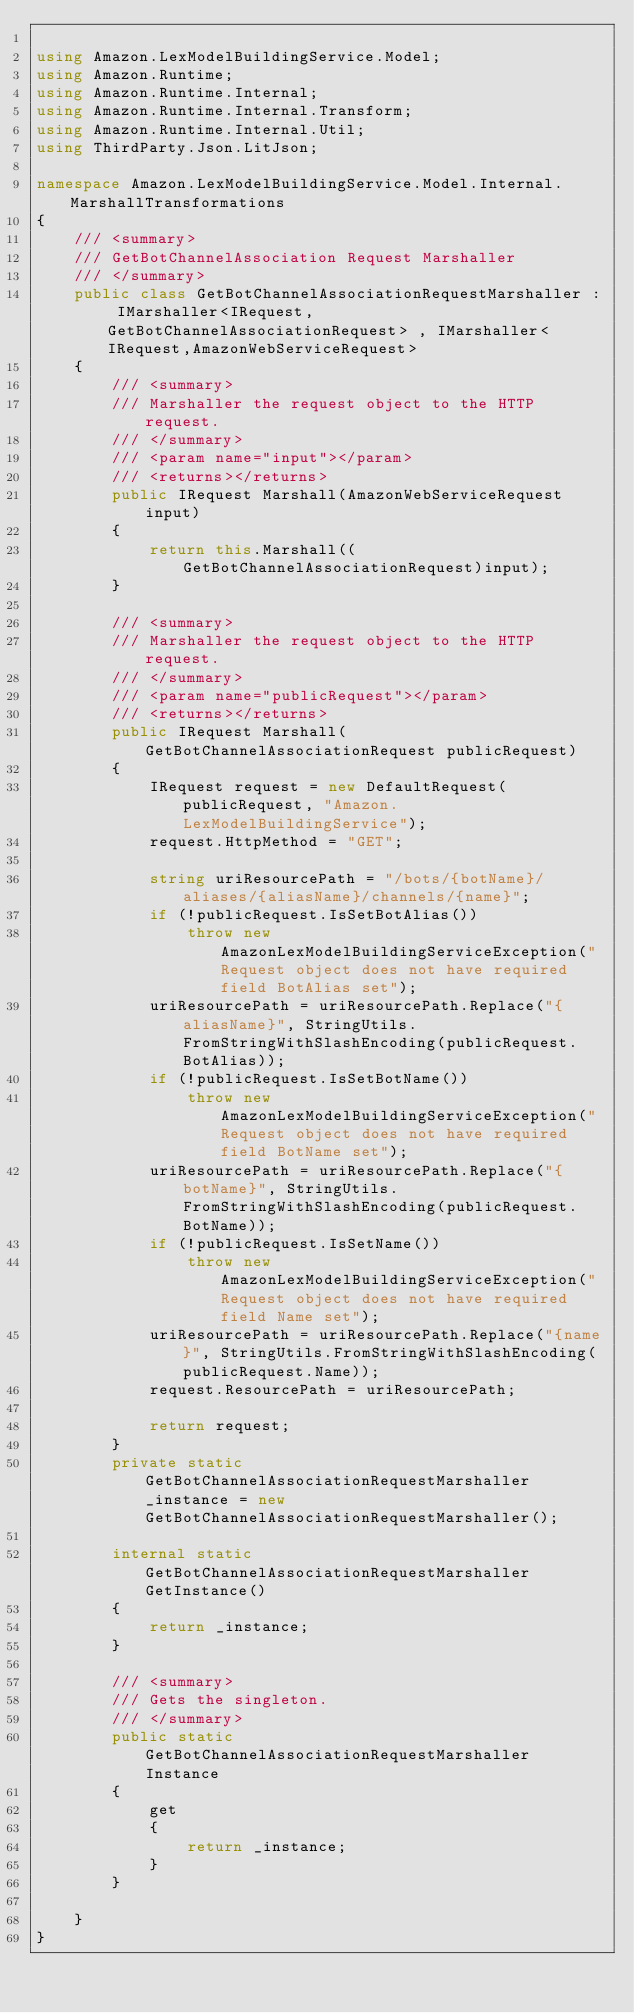<code> <loc_0><loc_0><loc_500><loc_500><_C#_>
using Amazon.LexModelBuildingService.Model;
using Amazon.Runtime;
using Amazon.Runtime.Internal;
using Amazon.Runtime.Internal.Transform;
using Amazon.Runtime.Internal.Util;
using ThirdParty.Json.LitJson;

namespace Amazon.LexModelBuildingService.Model.Internal.MarshallTransformations
{
    /// <summary>
    /// GetBotChannelAssociation Request Marshaller
    /// </summary>       
    public class GetBotChannelAssociationRequestMarshaller : IMarshaller<IRequest, GetBotChannelAssociationRequest> , IMarshaller<IRequest,AmazonWebServiceRequest>
    {
        /// <summary>
        /// Marshaller the request object to the HTTP request.
        /// </summary>  
        /// <param name="input"></param>
        /// <returns></returns>
        public IRequest Marshall(AmazonWebServiceRequest input)
        {
            return this.Marshall((GetBotChannelAssociationRequest)input);
        }

        /// <summary>
        /// Marshaller the request object to the HTTP request.
        /// </summary>  
        /// <param name="publicRequest"></param>
        /// <returns></returns>
        public IRequest Marshall(GetBotChannelAssociationRequest publicRequest)
        {
            IRequest request = new DefaultRequest(publicRequest, "Amazon.LexModelBuildingService");
            request.HttpMethod = "GET";

            string uriResourcePath = "/bots/{botName}/aliases/{aliasName}/channels/{name}";
            if (!publicRequest.IsSetBotAlias())
                throw new AmazonLexModelBuildingServiceException("Request object does not have required field BotAlias set");
            uriResourcePath = uriResourcePath.Replace("{aliasName}", StringUtils.FromStringWithSlashEncoding(publicRequest.BotAlias));
            if (!publicRequest.IsSetBotName())
                throw new AmazonLexModelBuildingServiceException("Request object does not have required field BotName set");
            uriResourcePath = uriResourcePath.Replace("{botName}", StringUtils.FromStringWithSlashEncoding(publicRequest.BotName));
            if (!publicRequest.IsSetName())
                throw new AmazonLexModelBuildingServiceException("Request object does not have required field Name set");
            uriResourcePath = uriResourcePath.Replace("{name}", StringUtils.FromStringWithSlashEncoding(publicRequest.Name));
            request.ResourcePath = uriResourcePath;

            return request;
        }
        private static GetBotChannelAssociationRequestMarshaller _instance = new GetBotChannelAssociationRequestMarshaller();        

        internal static GetBotChannelAssociationRequestMarshaller GetInstance()
        {
            return _instance;
        }

        /// <summary>
        /// Gets the singleton.
        /// </summary>  
        public static GetBotChannelAssociationRequestMarshaller Instance
        {
            get
            {
                return _instance;
            }
        }

    }
}</code> 